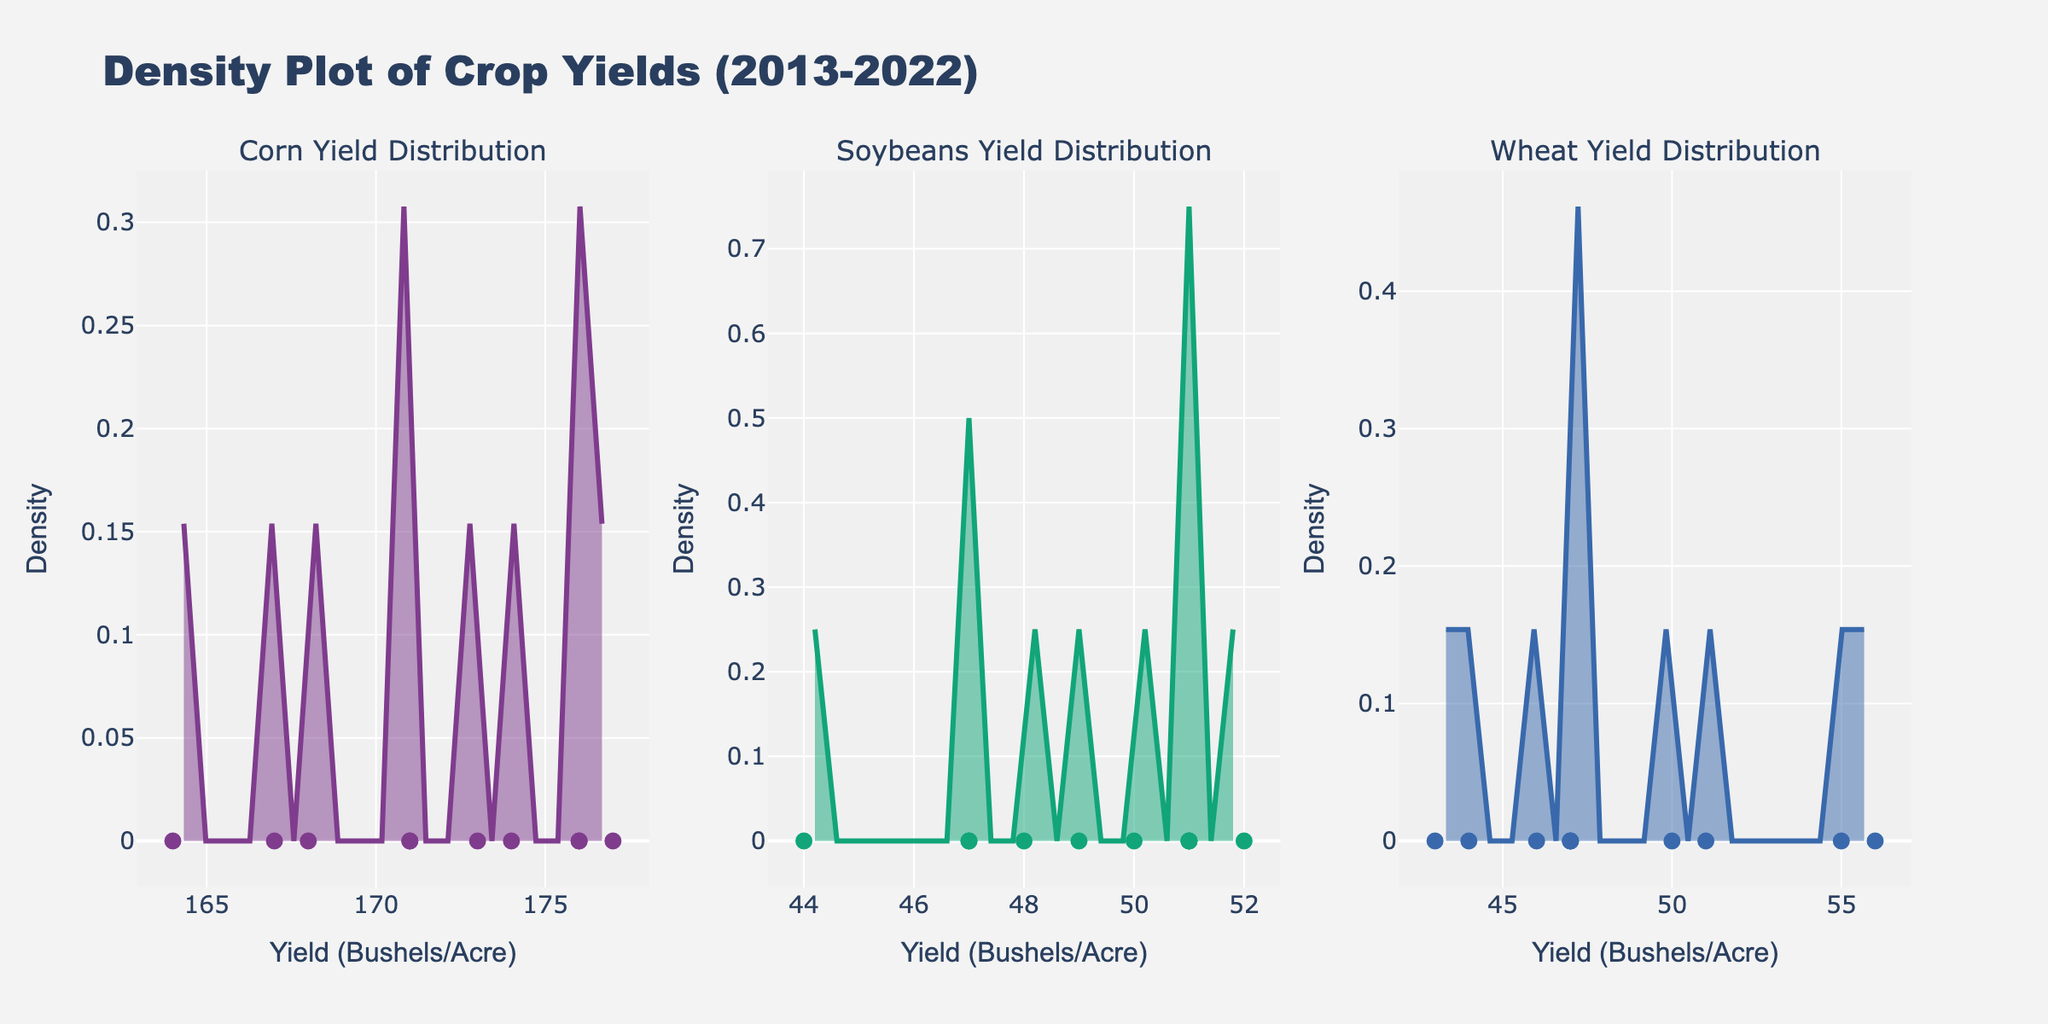What title is given to the plot? The title of the plot is provided at the top of the figure and it reads "Density Plot of Crop Yields (2013-2022)."
Answer: Density Plot of Crop Yields (2013-2022) How many crops are displayed in the plot? The plot consists of one subplot for each crop, and there are three subplots. Therefore, three crops are displayed.
Answer: 3 What is the x-axis label for all subplots? The x-axis label, visible under each subplot, is "Yield (Bushels/Acre)."
Answer: Yield (Bushels/Acre) Which crop has the highest peak density value? Looking across the subplots, Corn appears to have the highest peak in the density curve, indicating it has the highest peak density value.
Answer: Corn What is the range of yield for Soybeans? By observing the x-axis of the Soybeans subplot, the yield ranges from approximately 44 to 52 bushels per acre.
Answer: 44 - 52 bushels per acre Which crop shows the most variability in yields? To determine variability, we look at the spread of data points. Wheat shows the most variability with yields ranging from around 43 to 56 bushels per acre.
Answer: Wheat What is the approximate yield value where Corn has its highest density? In the Corn subplot, the highest peak of the density curve is around 174 bushels per acre.
Answer: 174 bushels per acre Are there any crops with overlapping yield distributions? By observing the density curves, it is clear that Corn and Soybeans have distinct distributions, as well as Wheat, without significant overlaps.
Answer: No How does the density plot of Wheat compare with the density plot of Soybeans in terms of spread? Wheat's density plot shows a wider spread of yield values compared to Soybeans, indicating greater variability in Wheat yields.
Answer: Wheat has a wider spread Which crop has the smallest yield range and what is that range? By examining the yields, Soybeans have the smallest range, spanning from 44 to 52 bushels per acre.
Answer: Soybeans, 44 - 52 bushels per acre 